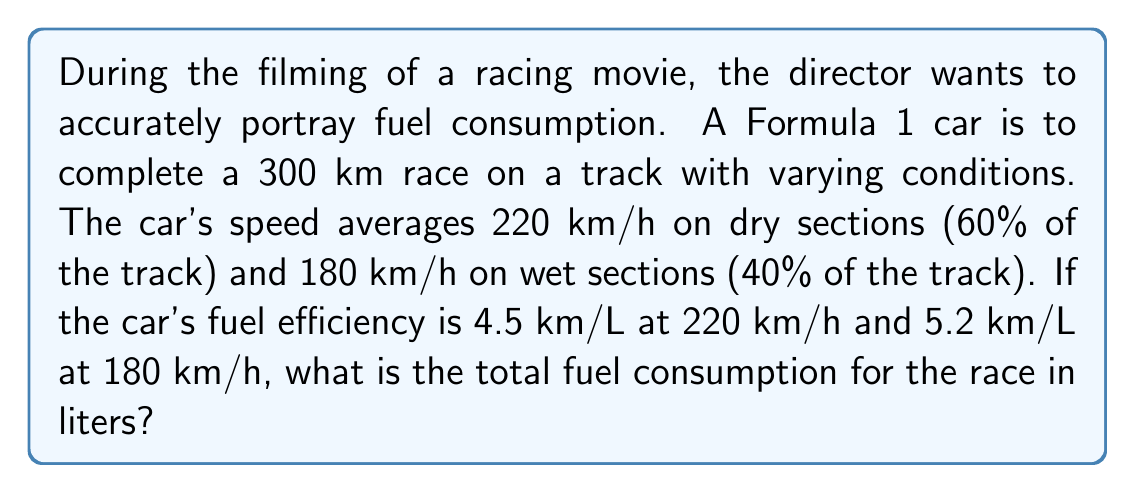Provide a solution to this math problem. 1. Calculate the distance for each track condition:
   Dry section: $300 \text{ km} \times 0.60 = 180 \text{ km}$
   Wet section: $300 \text{ km} \times 0.40 = 120 \text{ km}$

2. Calculate the time spent on each section:
   Dry section: $t_d = \frac{180 \text{ km}}{220 \text{ km/h}} = 0.8182 \text{ h}$
   Wet section: $t_w = \frac{120 \text{ km}}{180 \text{ km/h}} = 0.6667 \text{ h}$

3. Calculate fuel consumption for each section:
   Dry section: $F_d = \frac{180 \text{ km}}{4.5 \text{ km/L}} = 40 \text{ L}$
   Wet section: $F_w = \frac{120 \text{ km}}{5.2 \text{ km/L}} = 23.0769 \text{ L}$

4. Sum up the total fuel consumption:
   $F_{total} = F_d + F_w = 40 \text{ L} + 23.0769 \text{ L} = 63.0769 \text{ L}$

5. Round to two decimal places:
   $F_{total} \approx 63.08 \text{ L}$
Answer: 63.08 L 